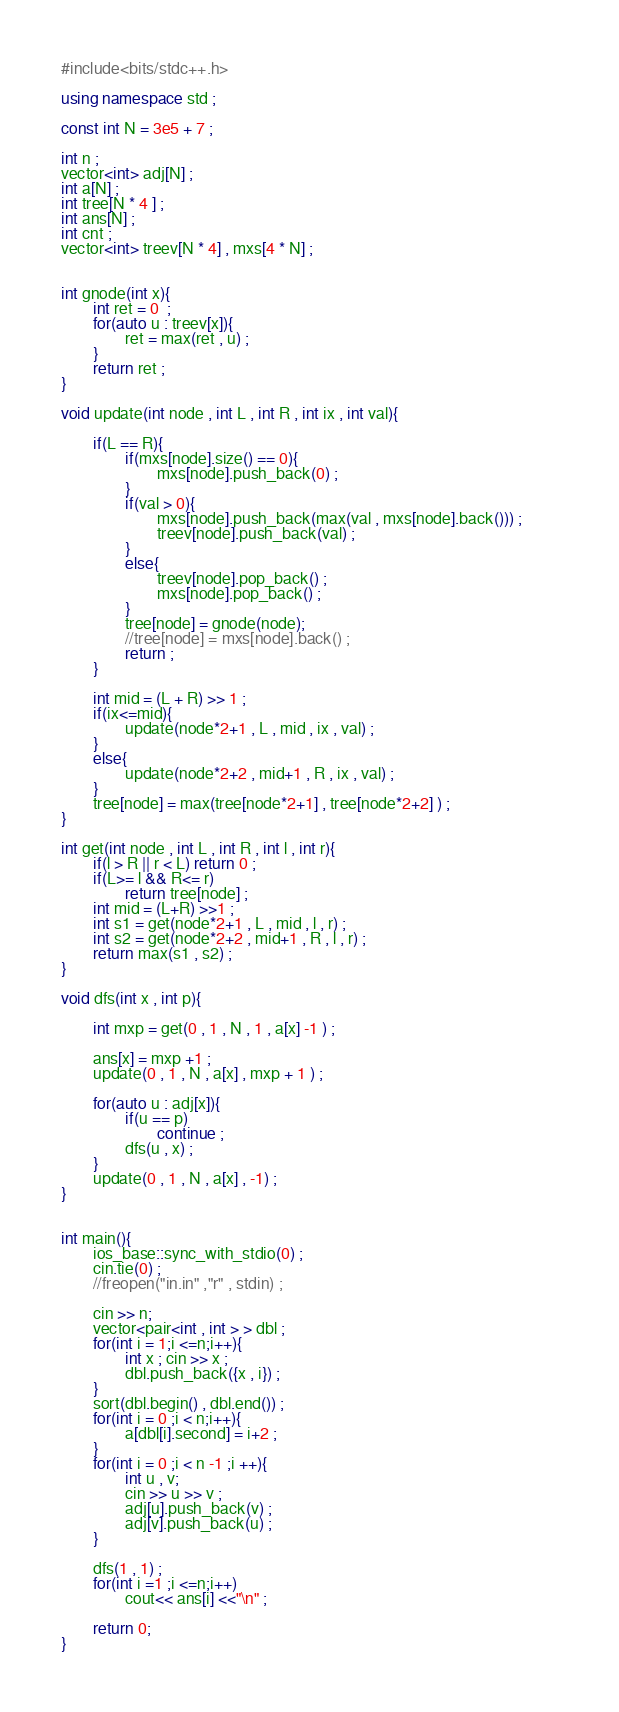Convert code to text. <code><loc_0><loc_0><loc_500><loc_500><_C++_>#include<bits/stdc++.h>

using namespace std ; 

const int N = 3e5 + 7 ; 

int n ; 
vector<int> adj[N] ; 
int a[N] ; 
int tree[N * 4 ] ; 
int ans[N] ; 
int cnt ; 
vector<int> treev[N * 4] , mxs[4 * N] ;  


int gnode(int x){
        int ret = 0  ; 
        for(auto u : treev[x]){
                ret = max(ret , u) ; 
        }
        return ret ; 
}

void update(int node , int L , int R , int ix , int val){

        if(L == R){
                if(mxs[node].size() == 0){
                        mxs[node].push_back(0) ;
                }
                if(val > 0){
                        mxs[node].push_back(max(val , mxs[node].back())) ;         
                        treev[node].push_back(val) ;              
                }
                else{
                        treev[node].pop_back() ; 
                        mxs[node].pop_back() ; 
                }
                tree[node] = gnode(node);
                //tree[node] = mxs[node].back() ; 
                return ; 
        }

        int mid = (L + R) >> 1 ; 
        if(ix<=mid){
                update(node*2+1 , L , mid , ix , val) ; 
        }
        else{   
                update(node*2+2 , mid+1 , R , ix , val) ; 
        }
        tree[node] = max(tree[node*2+1] , tree[node*2+2] ) ; 
}

int get(int node , int L , int R , int l , int r){      
        if(l > R || r < L) return 0 ; 
        if(L>= l && R<= r)
                return tree[node] ; 
        int mid = (L+R) >>1 ; 
        int s1 = get(node*2+1 , L , mid , l , r) ; 
        int s2 = get(node*2+2 , mid+1 , R , l , r) ; 
        return max(s1 , s2) ;
}

void dfs(int x , int p){

        int mxp = get(0 , 1 , N , 1 , a[x] -1 ) ; 

        ans[x] = mxp +1 ; 
        update(0 , 1 , N , a[x] , mxp + 1 ) ; 

        for(auto u : adj[x]){
                if(u == p)
                        continue ; 
                dfs(u , x) ;        
        }
        update(0 , 1 , N , a[x] , -1) ; 
}


int main(){
        ios_base::sync_with_stdio(0) ; 
        cin.tie(0) ; 
        //freopen("in.in" ,"r" , stdin) ; 

        cin >> n; 
        vector<pair<int , int > > dbl ; 
        for(int i = 1;i <=n;i++){
                int x ; cin >> x ; 
                dbl.push_back({x , i}) ; 
        }
        sort(dbl.begin() , dbl.end()) ; 
        for(int i = 0 ;i < n;i++){
                a[dbl[i].second] = i+2 ; 
        }
        for(int i = 0 ;i < n -1 ;i ++){
                int u , v; 
                cin >> u >> v ; 
                adj[u].push_back(v) ; 
                adj[v].push_back(u) ; 
        }

        dfs(1 , 1) ; 
        for(int i =1 ;i <=n;i++)
                cout<< ans[i] <<"\n" ; 

        return 0; 
}</code> 